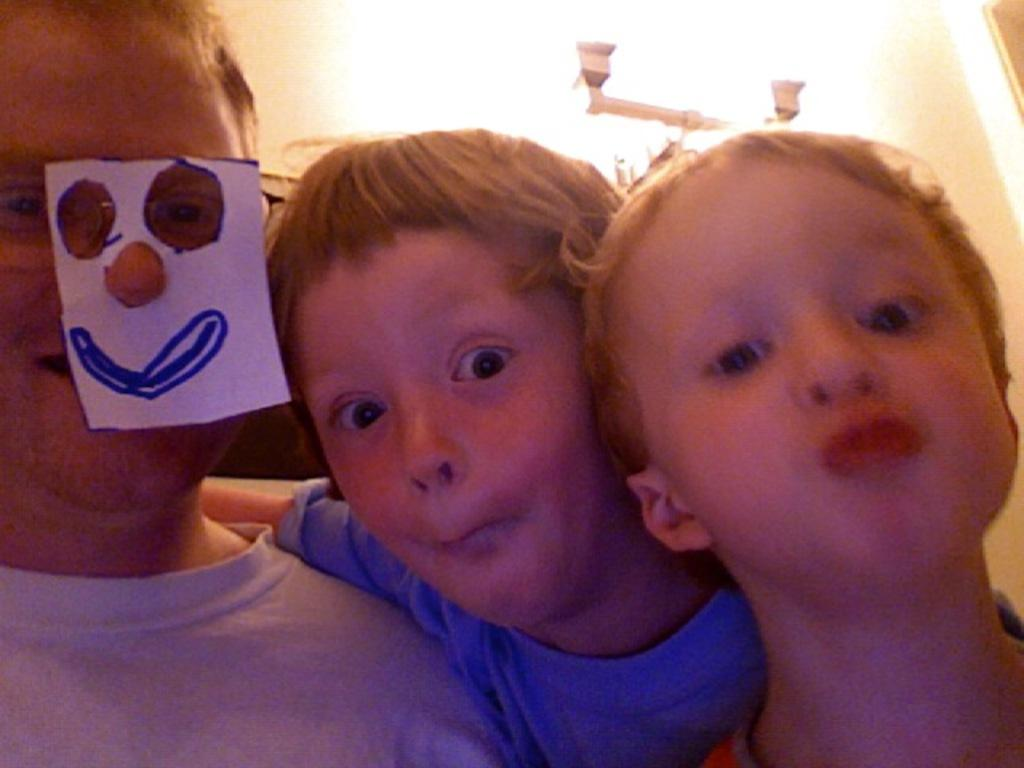How many people are in the foreground of the picture? There are three persons in the foreground of the picture. What can be seen in the background of the picture? There is a wall, a light, a stand, and other objects in the background of the picture. How many rabbits can be seen playing on the patch in the image? There are no rabbits or patches present in the image. What type of art is displayed on the wall in the image? The provided facts do not mention any art on the wall, so we cannot determine if any art is displayed. 